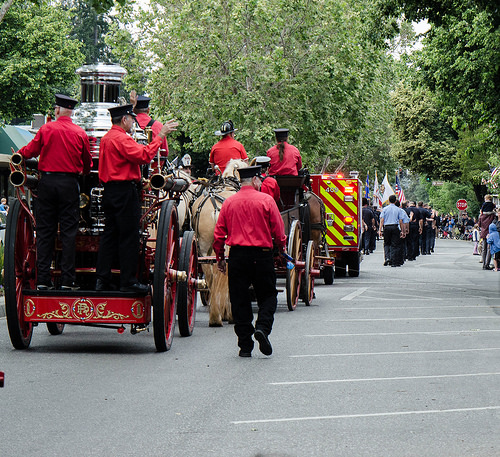<image>
Is the wheel to the left of the man? Yes. From this viewpoint, the wheel is positioned to the left side relative to the man. 